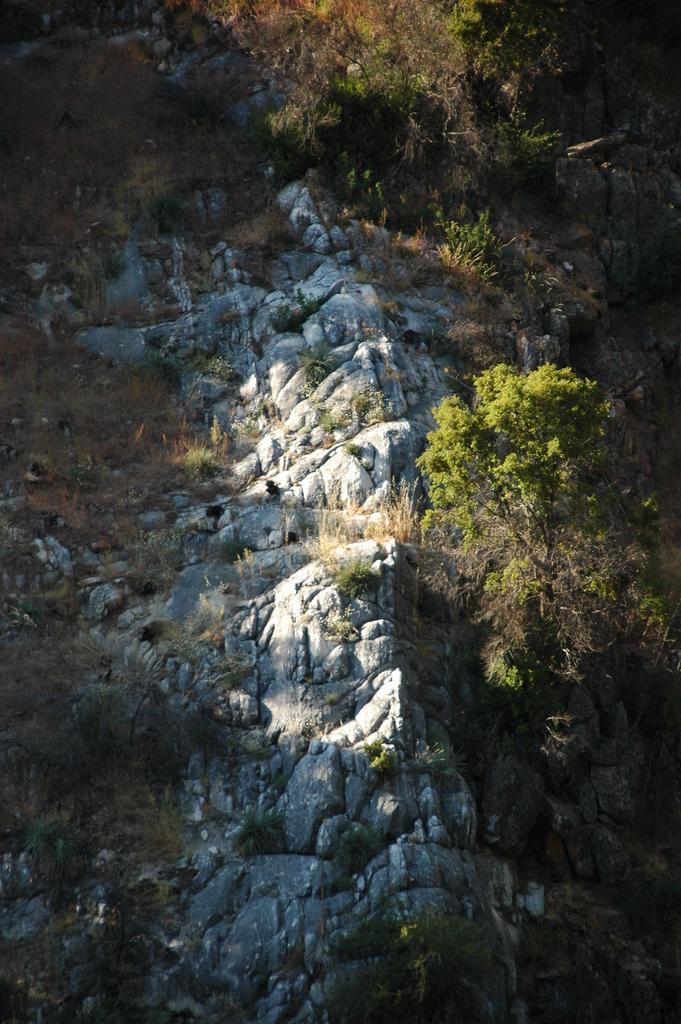How would you summarize this image in a sentence or two? In this picture we can see rocks and in the background we can see trees. 